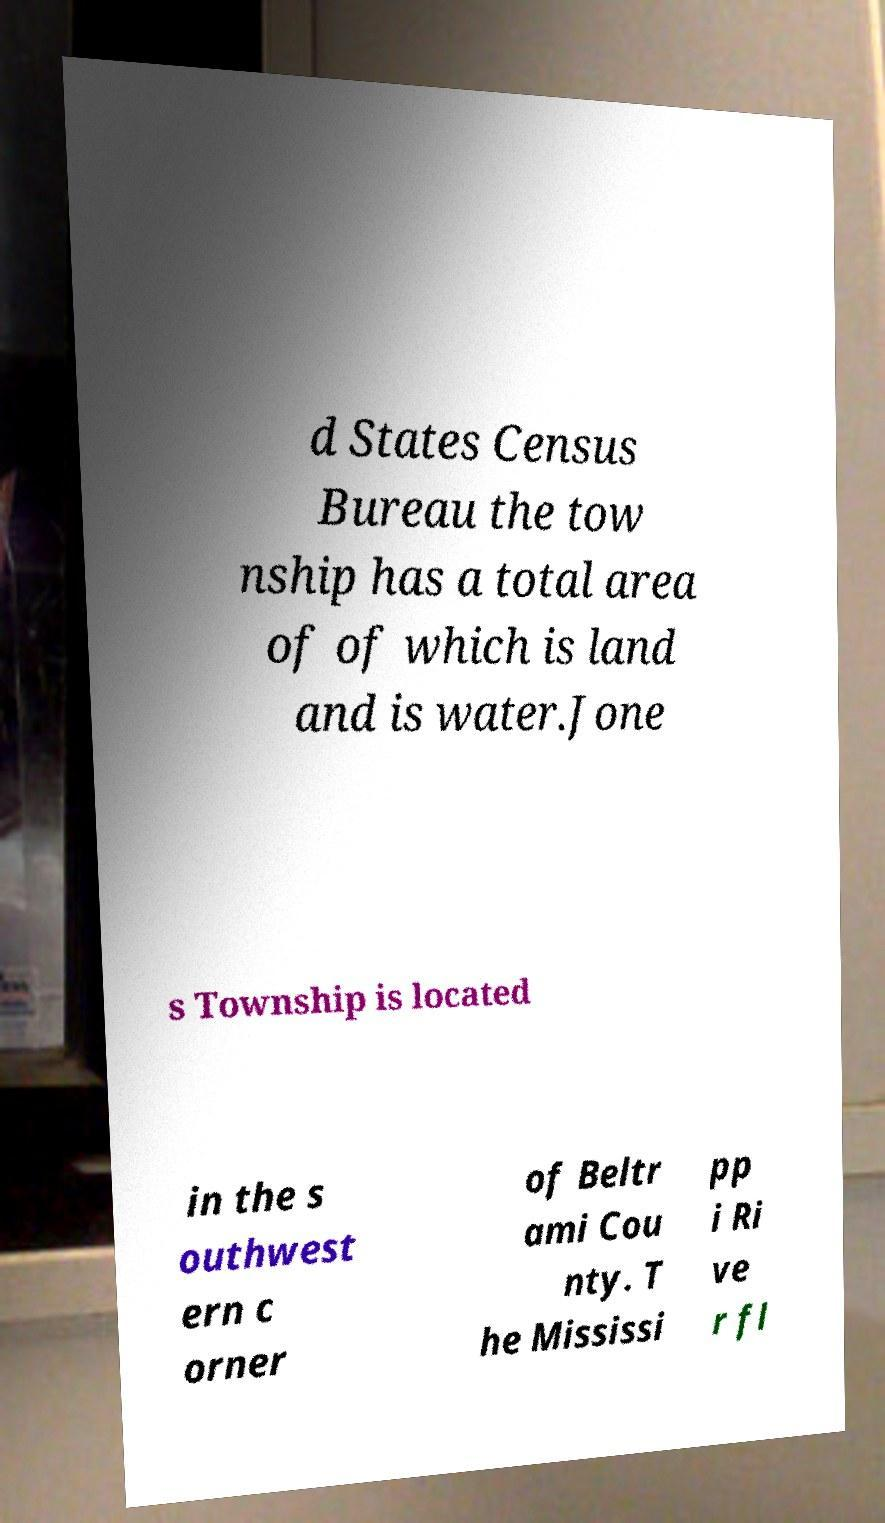Could you assist in decoding the text presented in this image and type it out clearly? d States Census Bureau the tow nship has a total area of of which is land and is water.Jone s Township is located in the s outhwest ern c orner of Beltr ami Cou nty. T he Mississi pp i Ri ve r fl 